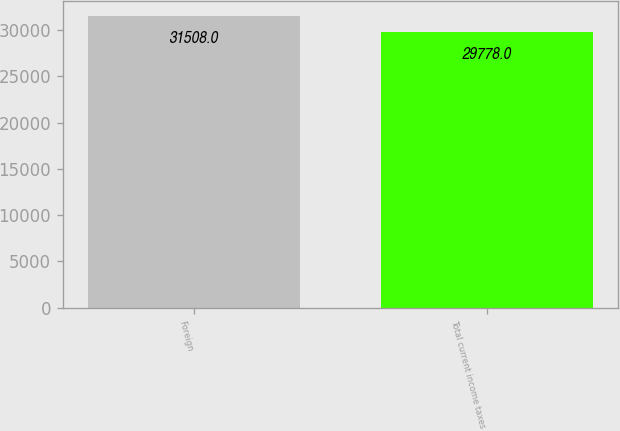<chart> <loc_0><loc_0><loc_500><loc_500><bar_chart><fcel>Foreign<fcel>Total current income taxes<nl><fcel>31508<fcel>29778<nl></chart> 